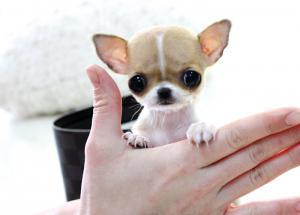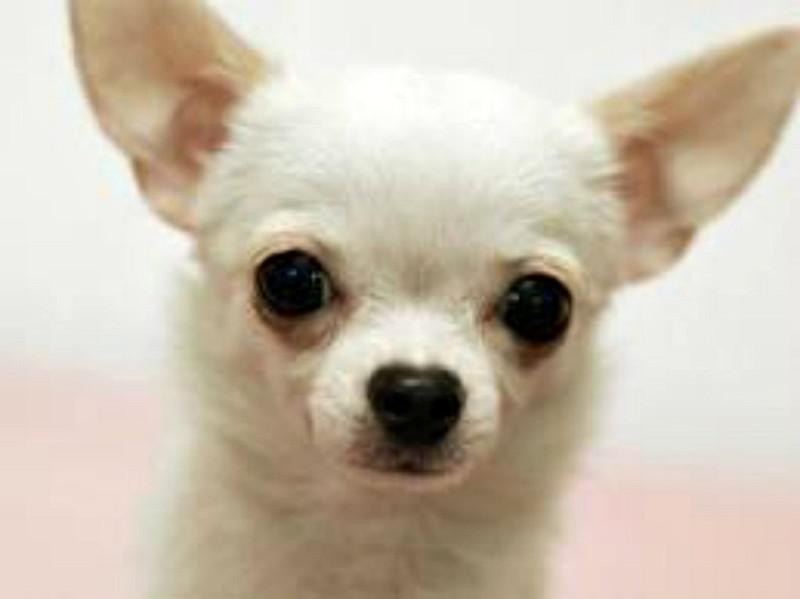The first image is the image on the left, the second image is the image on the right. Assess this claim about the two images: "There are two puppies and at least one of them is not looking at the camera.". Correct or not? Answer yes or no. No. 